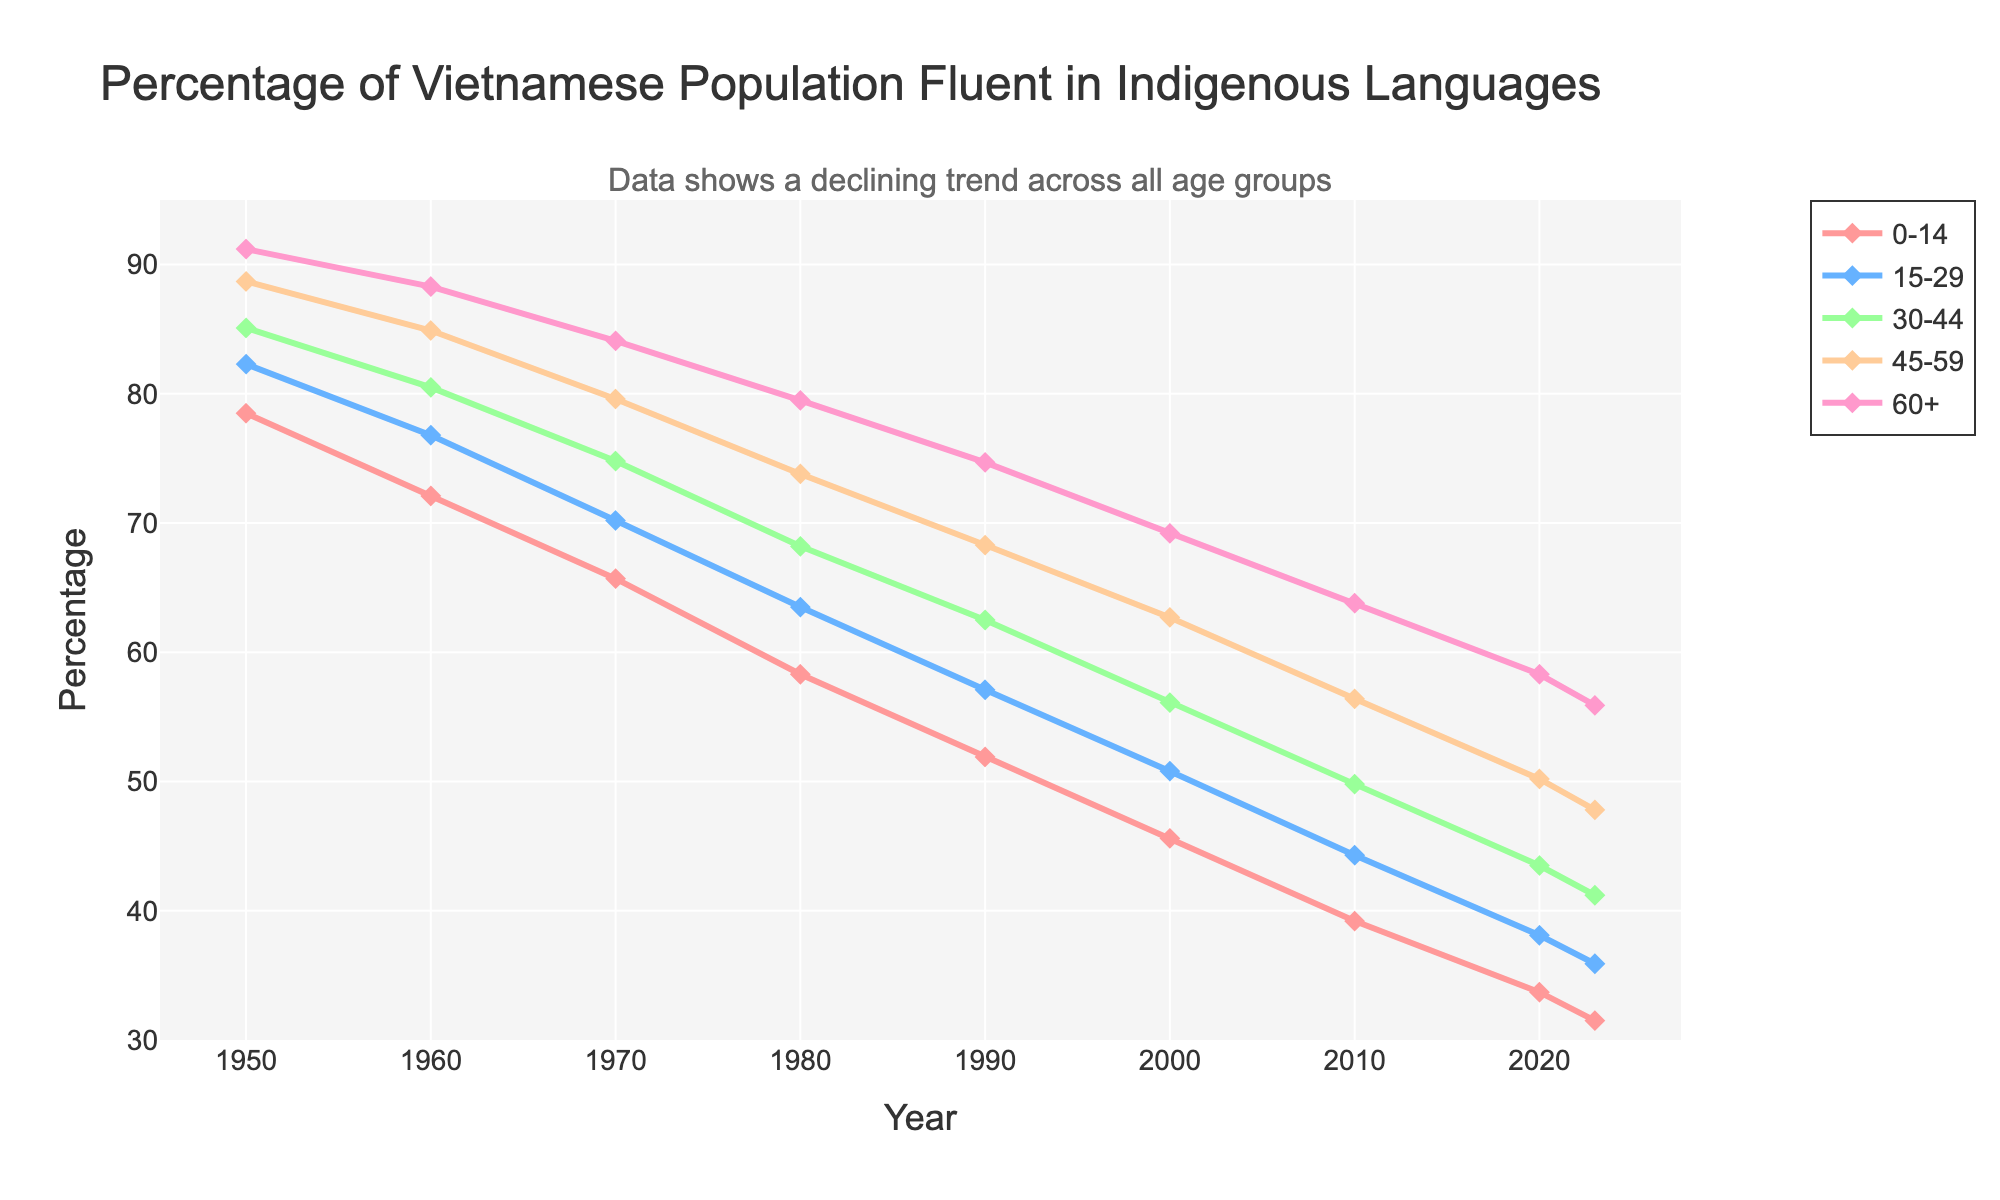What is the general trend for the percentage of the Vietnamese population fluent in indigenous languages across all age groups from 1950 to 2023? The general trend for all age groups shows a steady decline in the percentage of the population fluent in indigenous languages. By looking at each line representing different age groups, all of them consistently decrease over the years.
Answer: Declining Which age group had the highest percentage of fluency in indigenous languages in 1950? In 1950, the age group 60+ had the highest percentage of fluency in indigenous languages, as indicated by the highest point on the graph among all age groups in that year.
Answer: 60+ How much did the percentage of fluency in indigenous languages decrease for the age group 45-59 from 1950 to 2023? In 1950, the age group 45-59 had a fluency percentage of 88.7%, and in 2023, it was 47.8%. The decrease is calculated as 88.7% - 47.8% = 40.9%.
Answer: 40.9% Which two age groups had almost the same percentage of fluency in indigenous languages in 2023, and what is that percentage? In 2023, the age groups 0-14 and 15-29 had almost the same percentage of fluency. Inspecting the values, 0-14 had 31.5% and 15-29 had 35.9%, which are close to each other.
Answer: 31.5% (0-14), 35.9% (15-29) In which decade did the age group 0-14 experience the sharpest decline in fluency percentage? The decade from 1970 to 1980 saw the sharpest decline for the age group 0-14. The percentage dropped from 65.7% in 1970 to 58.3% in 1980, a decrease of 7.4%.
Answer: 1970-1980 Compare the decline in fluency percentage for age groups 0-14 and 30-44 from 1950 to 2023. Which age group had a larger decline? For age group 0-14, the fluency percentage decreased from 78.5% in 1950 to 31.5% in 2023, a drop of 47%. For age group 30-44, the decrease was from 85.1% to 41.2%, a drop of 43.9%. The decline was larger for age group 0-14.
Answer: 0-14 What is the difference in the percentage of fluent speakers between the oldest and youngest age groups in 2023? In 2023, the oldest age group (60+) had a fluency rate of 55.9%, while the youngest age group (0-14) had 31.5%. The difference is 55.9% - 31.5% = 24.4%.
Answer: 24.4% On visual inspection, which color represents the age group of 30-44 years old, and how do you know? The age group 30-44 is represented by the line that is colored green. By visually inspecting the legend, we can see the green color is associated with the 30-44 age group.
Answer: Green 